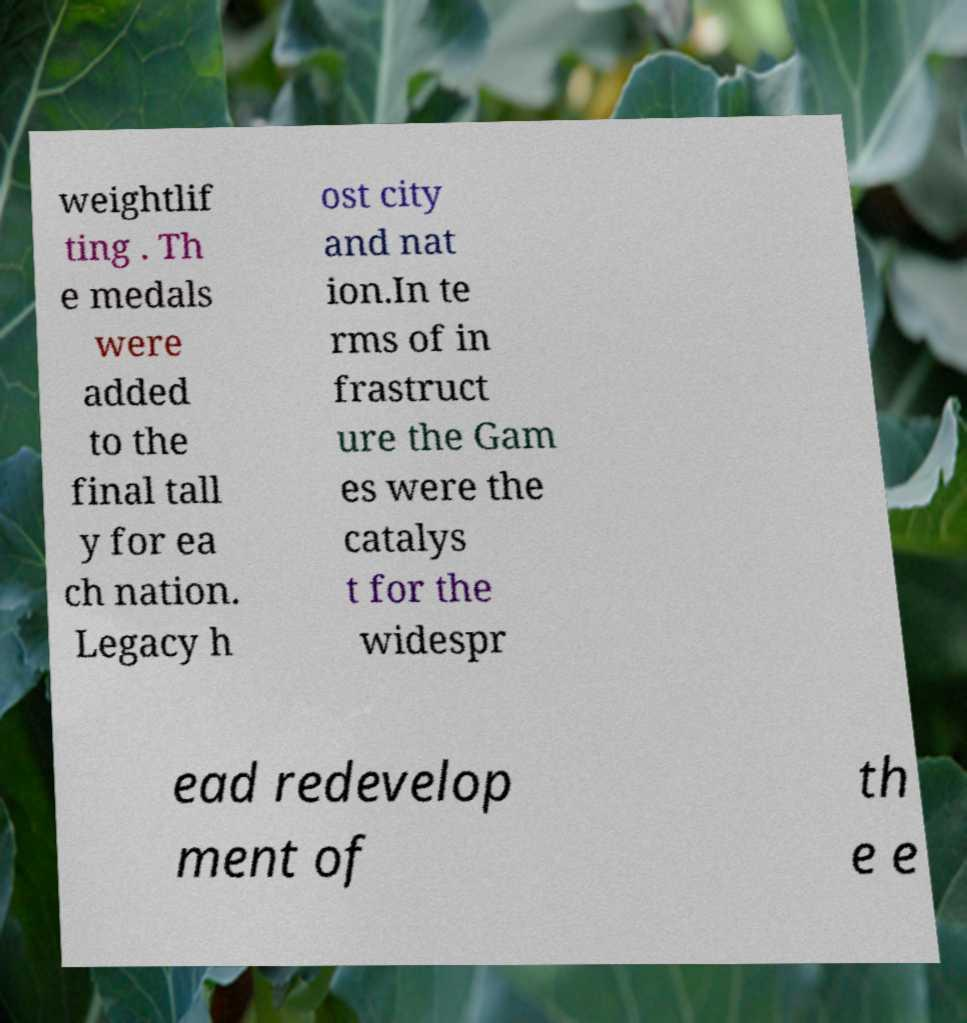For documentation purposes, I need the text within this image transcribed. Could you provide that? weightlif ting . Th e medals were added to the final tall y for ea ch nation. Legacy h ost city and nat ion.In te rms of in frastruct ure the Gam es were the catalys t for the widespr ead redevelop ment of th e e 